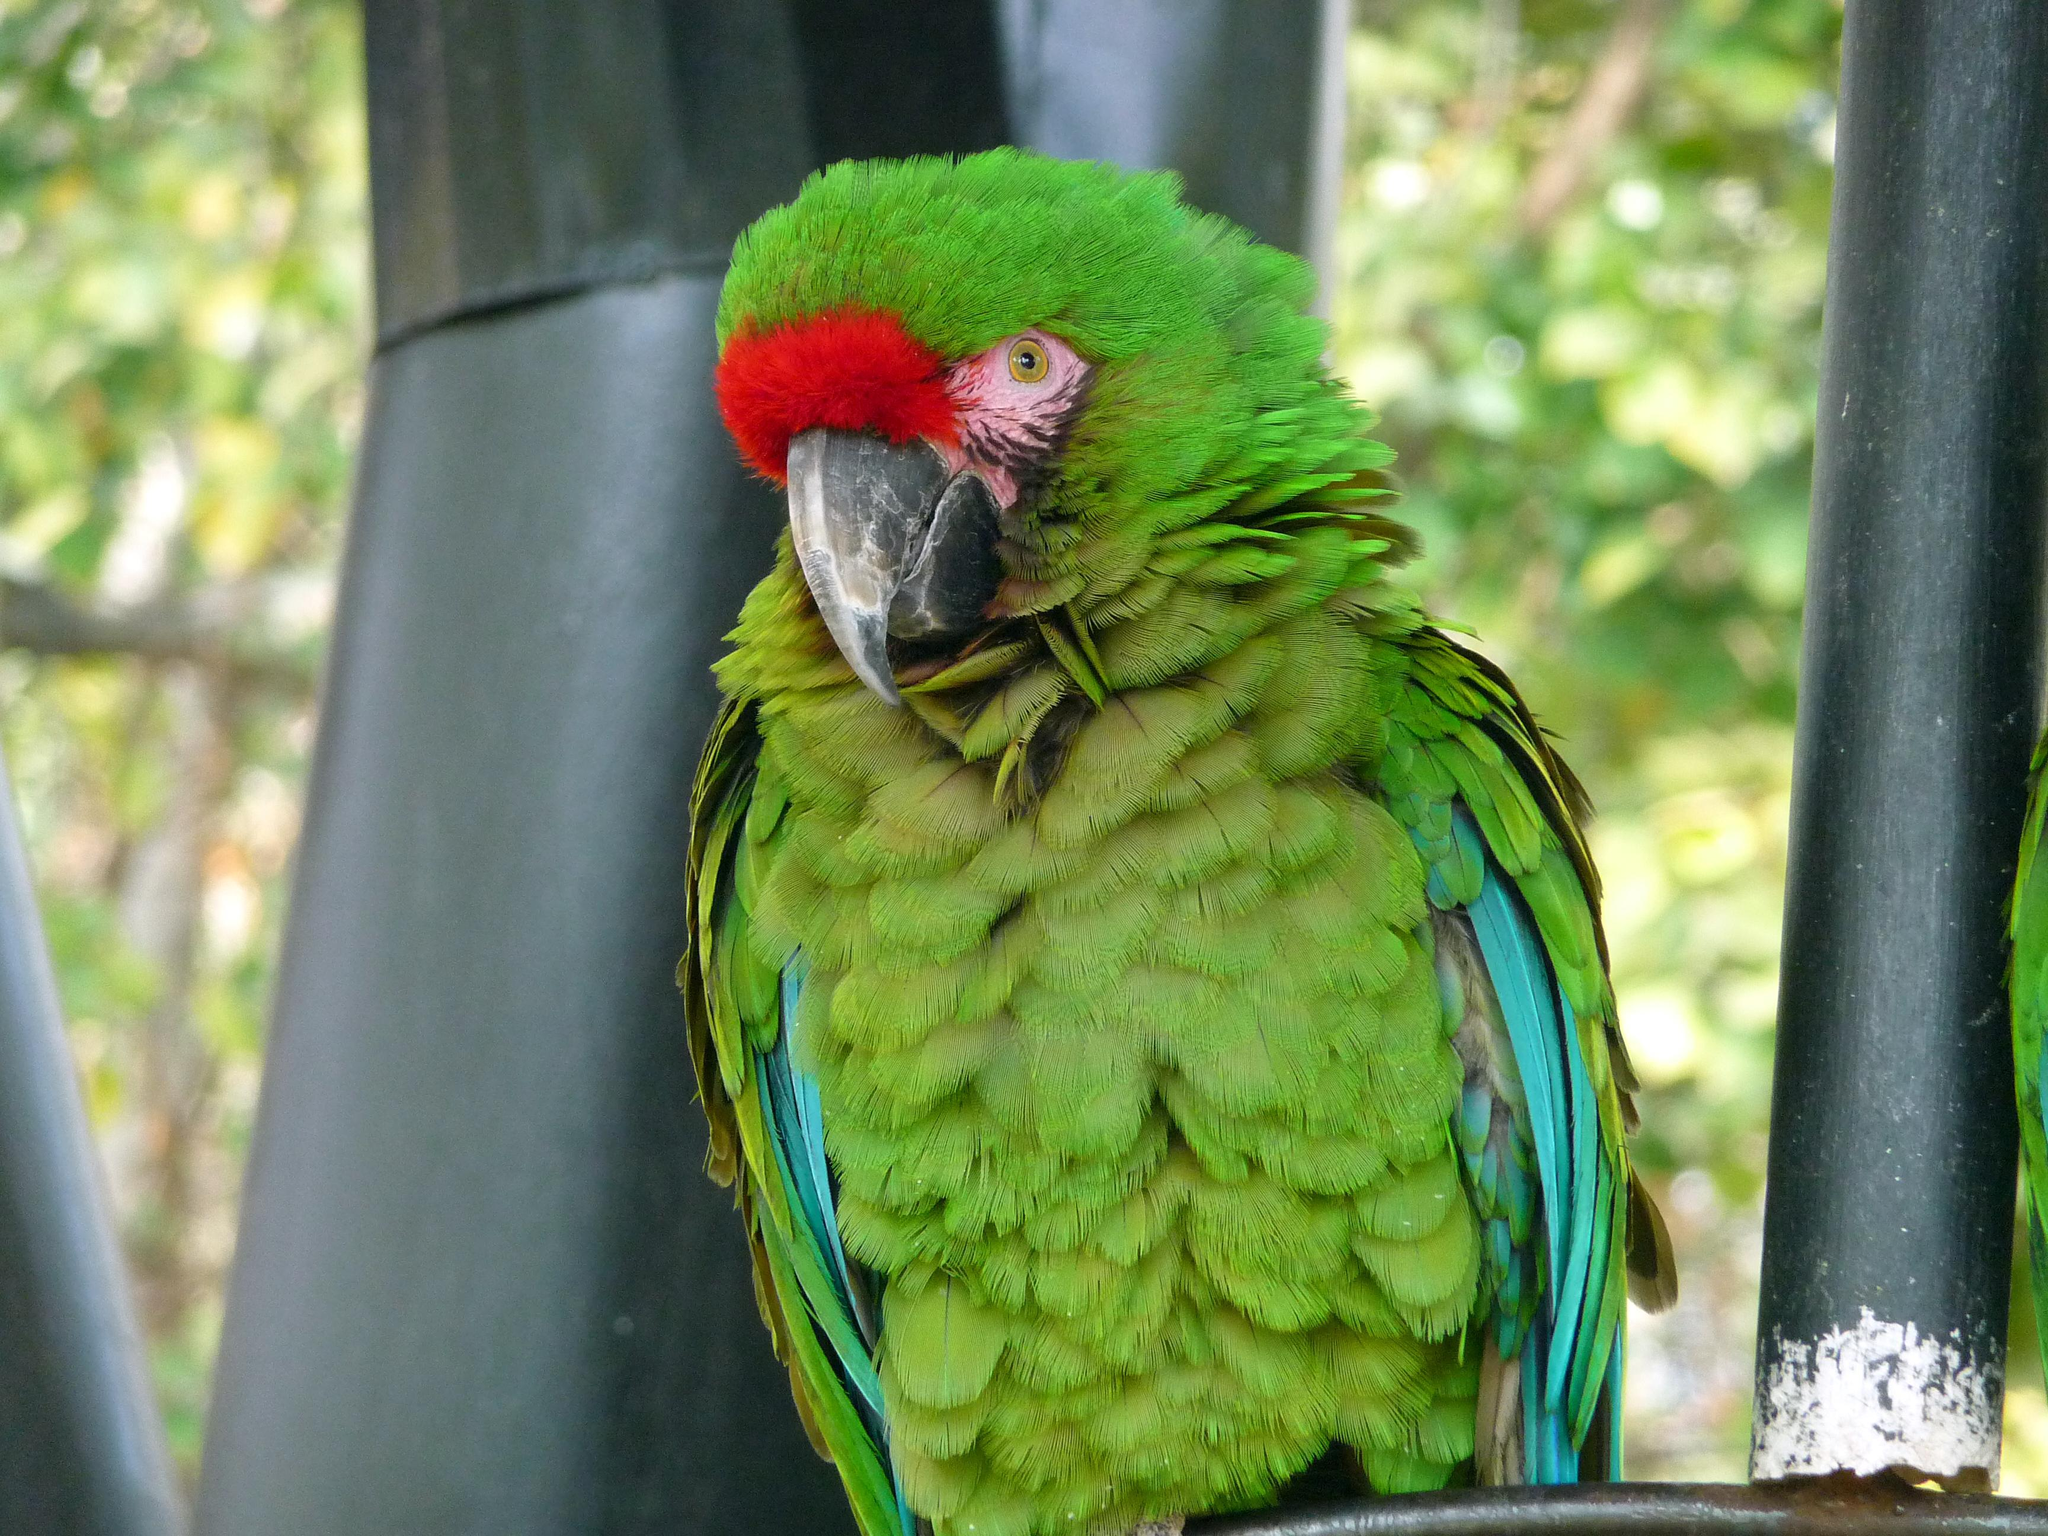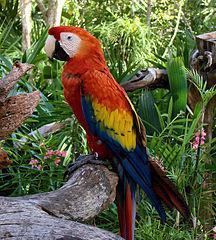The first image is the image on the left, the second image is the image on the right. For the images shown, is this caption "In one image two parrots are standing on a branch and in the other there's only one parrot" true? Answer yes or no. No. 